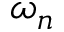Convert formula to latex. <formula><loc_0><loc_0><loc_500><loc_500>\omega _ { n }</formula> 